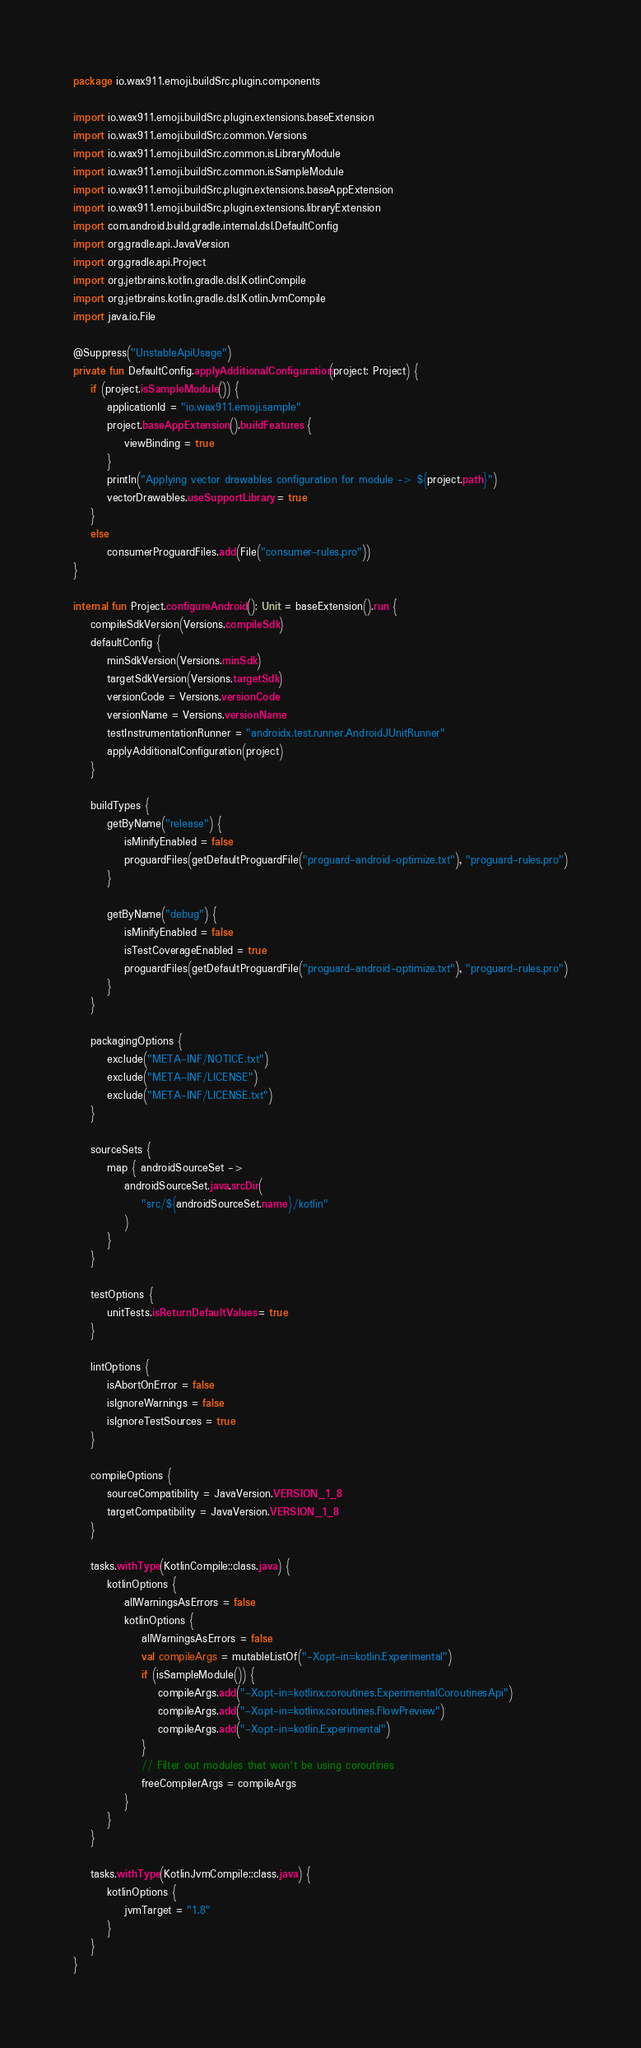<code> <loc_0><loc_0><loc_500><loc_500><_Kotlin_>package io.wax911.emoji.buildSrc.plugin.components

import io.wax911.emoji.buildSrc.plugin.extensions.baseExtension
import io.wax911.emoji.buildSrc.common.Versions
import io.wax911.emoji.buildSrc.common.isLibraryModule
import io.wax911.emoji.buildSrc.common.isSampleModule
import io.wax911.emoji.buildSrc.plugin.extensions.baseAppExtension
import io.wax911.emoji.buildSrc.plugin.extensions.libraryExtension
import com.android.build.gradle.internal.dsl.DefaultConfig
import org.gradle.api.JavaVersion
import org.gradle.api.Project
import org.jetbrains.kotlin.gradle.dsl.KotlinCompile
import org.jetbrains.kotlin.gradle.dsl.KotlinJvmCompile
import java.io.File

@Suppress("UnstableApiUsage")
private fun DefaultConfig.applyAdditionalConfiguration(project: Project) {
    if (project.isSampleModule()) {
        applicationId = "io.wax911.emoji.sample"
        project.baseAppExtension().buildFeatures {
            viewBinding = true
        }
        println("Applying vector drawables configuration for module -> ${project.path}")
        vectorDrawables.useSupportLibrary = true
    }
    else
        consumerProguardFiles.add(File("consumer-rules.pro"))
}

internal fun Project.configureAndroid(): Unit = baseExtension().run {
    compileSdkVersion(Versions.compileSdk)
    defaultConfig {
        minSdkVersion(Versions.minSdk)
        targetSdkVersion(Versions.targetSdk)
        versionCode = Versions.versionCode
        versionName = Versions.versionName
        testInstrumentationRunner = "androidx.test.runner.AndroidJUnitRunner"
        applyAdditionalConfiguration(project)
    }

    buildTypes {
        getByName("release") {
            isMinifyEnabled = false
            proguardFiles(getDefaultProguardFile("proguard-android-optimize.txt"), "proguard-rules.pro")
        }

        getByName("debug") {
            isMinifyEnabled = false
            isTestCoverageEnabled = true
            proguardFiles(getDefaultProguardFile("proguard-android-optimize.txt"), "proguard-rules.pro")
        }
    }

    packagingOptions {
        exclude("META-INF/NOTICE.txt")
        exclude("META-INF/LICENSE")
        exclude("META-INF/LICENSE.txt")
    }

    sourceSets {
        map { androidSourceSet ->
            androidSourceSet.java.srcDir(
                "src/${androidSourceSet.name}/kotlin"
            )
        }
    }

    testOptions {
        unitTests.isReturnDefaultValues = true
    }

    lintOptions {
        isAbortOnError = false
        isIgnoreWarnings = false
        isIgnoreTestSources = true
    }

    compileOptions {
        sourceCompatibility = JavaVersion.VERSION_1_8
        targetCompatibility = JavaVersion.VERSION_1_8
    }

    tasks.withType(KotlinCompile::class.java) {
        kotlinOptions {
            allWarningsAsErrors = false
            kotlinOptions {
                allWarningsAsErrors = false
                val compileArgs = mutableListOf("-Xopt-in=kotlin.Experimental")
                if (isSampleModule()) {
                    compileArgs.add("-Xopt-in=kotlinx.coroutines.ExperimentalCoroutinesApi")
                    compileArgs.add("-Xopt-in=kotlinx.coroutines.FlowPreview")
                    compileArgs.add("-Xopt-in=kotlin.Experimental")
                }
                // Filter out modules that won't be using coroutines
                freeCompilerArgs = compileArgs
            }
        }
    }

    tasks.withType(KotlinJvmCompile::class.java) {
        kotlinOptions {
            jvmTarget = "1.8"
        }
    }
}</code> 